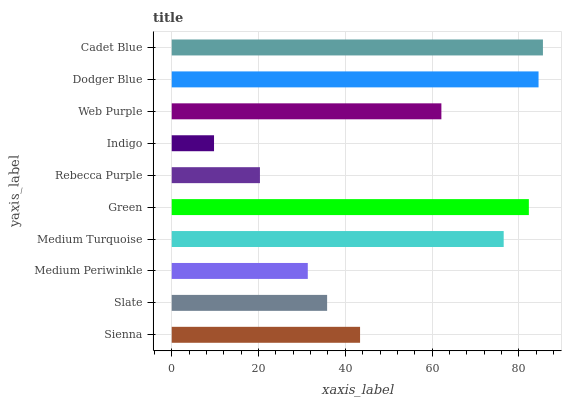Is Indigo the minimum?
Answer yes or no. Yes. Is Cadet Blue the maximum?
Answer yes or no. Yes. Is Slate the minimum?
Answer yes or no. No. Is Slate the maximum?
Answer yes or no. No. Is Sienna greater than Slate?
Answer yes or no. Yes. Is Slate less than Sienna?
Answer yes or no. Yes. Is Slate greater than Sienna?
Answer yes or no. No. Is Sienna less than Slate?
Answer yes or no. No. Is Web Purple the high median?
Answer yes or no. Yes. Is Sienna the low median?
Answer yes or no. Yes. Is Sienna the high median?
Answer yes or no. No. Is Slate the low median?
Answer yes or no. No. 